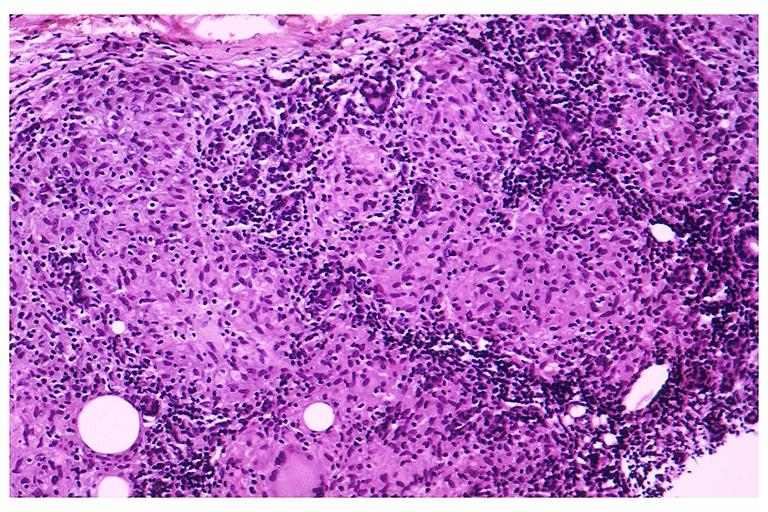where is this?
Answer the question using a single word or phrase. Oral 